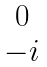Convert formula to latex. <formula><loc_0><loc_0><loc_500><loc_500>\begin{matrix} \, 0 \\ \, - i \end{matrix}</formula> 